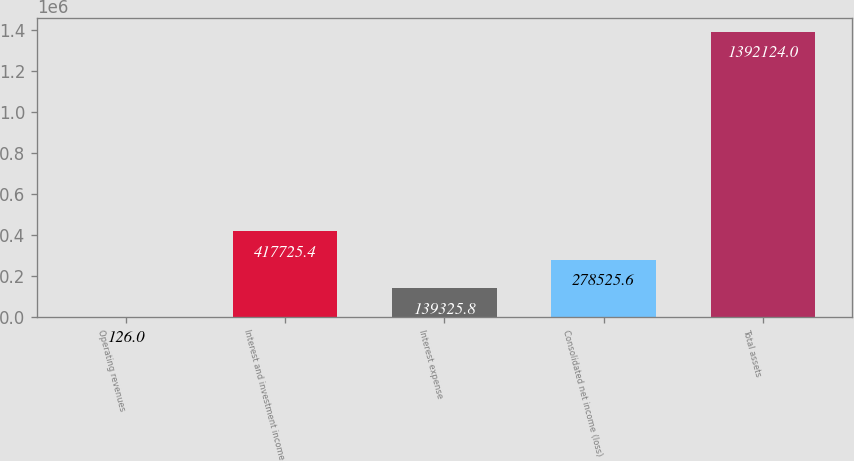Convert chart to OTSL. <chart><loc_0><loc_0><loc_500><loc_500><bar_chart><fcel>Operating revenues<fcel>Interest and investment income<fcel>Interest expense<fcel>Consolidated net income (loss)<fcel>Total assets<nl><fcel>126<fcel>417725<fcel>139326<fcel>278526<fcel>1.39212e+06<nl></chart> 